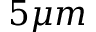Convert formula to latex. <formula><loc_0><loc_0><loc_500><loc_500>5 \mu m</formula> 